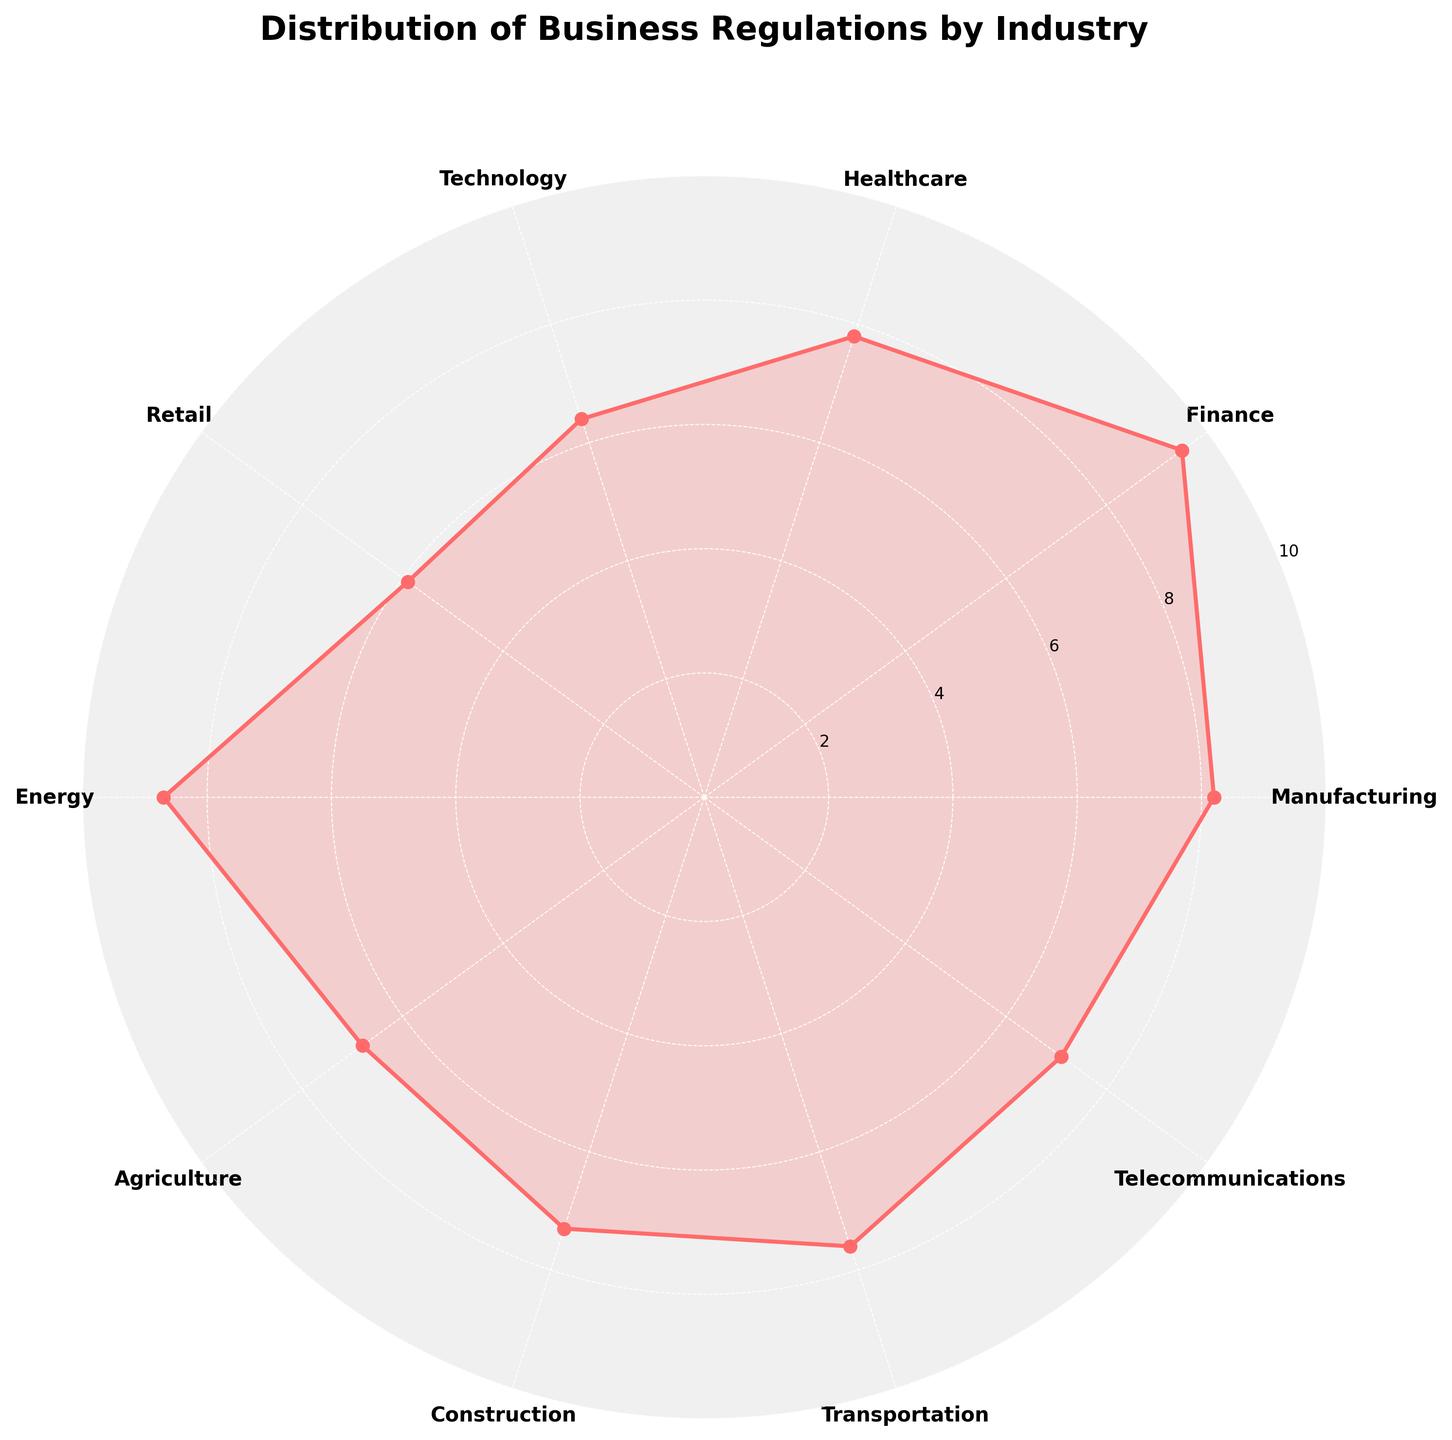what is the title of the chart? The title is displayed at the top of the chart. Read it directly.
Answer: Distribution of Business Regulations by Industry Which industry has the highest regulation level? Look for the industry that corresponds to the highest-value point on the radial axis.
Answer: Finance Which industries have a regulation level above 8? Identify all labels (industries) where the radial axis level is above 8.
Answer: Manufacturing, Finance, Energy What is the average regulation level for all industries? Sum all the regulation levels and then divide by the number of industries (10). Calculation: (8.2 + 9.5 + 7.8 + 6.4 + 5.9 + 8.7 + 6.8 + 7.3 + 7.6 + 7.1) / 10 = 75.3 / 10 = 7.53
Answer: 7.53 Which industry has the lowest regulation level? Find the industry that corresponds to the lowest value on the radial axis.
Answer: Retail Compare the regulation levels between Healthcare and Energy. Which has higher regulation? Look at the radial axis levels for both Healthcare and Energy, and compare them.
Answer: Energy What is the range of regulation levels shown in the chart? Subtract the lowest regulation level from the highest. Calculation: 9.5 (Finance) - 5.9 (Retail) = 3.6
Answer: 3.6 How many industries have a regulation level between 7 and 8? Count all the instances where the regulation level falls within the range of 7 to 8.
Answer: 4 (Healthcare, Agriculture, Construction, Telecommunications) What's the median regulation level for these industries? Arrange the regulation levels in ascending order and find the middle value(s). The median is the average of the 5th and 6th values: (7.3 + 7.6) / 2 = 7.45
Answer: 7.45 Compare Transportation and Technology. Which has a lower regulation level and by how much? Find and compare the regulation levels of both industries. Subtract the lower value from the higher one. Calculation: 7.6 (Transportation) - 6.4 (Technology) = 1.2
Answer: 1.2 